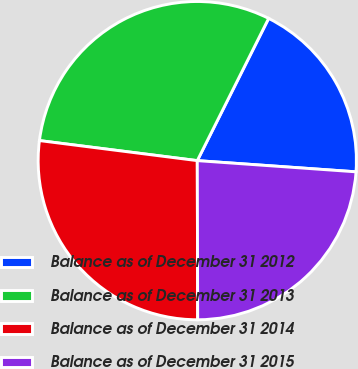Convert chart. <chart><loc_0><loc_0><loc_500><loc_500><pie_chart><fcel>Balance as of December 31 2012<fcel>Balance as of December 31 2013<fcel>Balance as of December 31 2014<fcel>Balance as of December 31 2015<nl><fcel>18.72%<fcel>30.39%<fcel>27.05%<fcel>23.84%<nl></chart> 